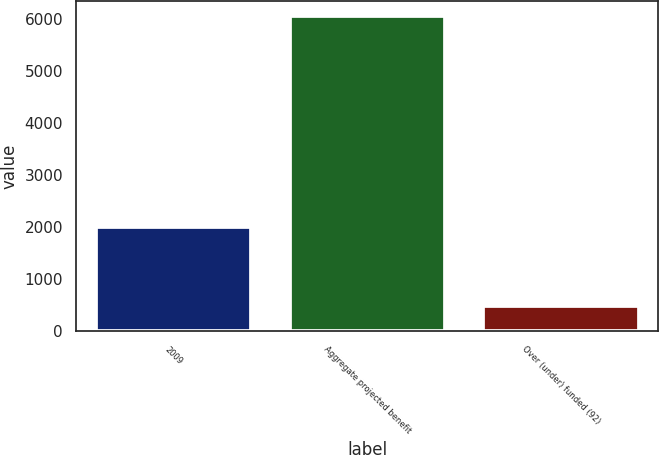Convert chart. <chart><loc_0><loc_0><loc_500><loc_500><bar_chart><fcel>2009<fcel>Aggregate projected benefit<fcel>Over (under) funded (92)<nl><fcel>2008<fcel>6041<fcel>482<nl></chart> 